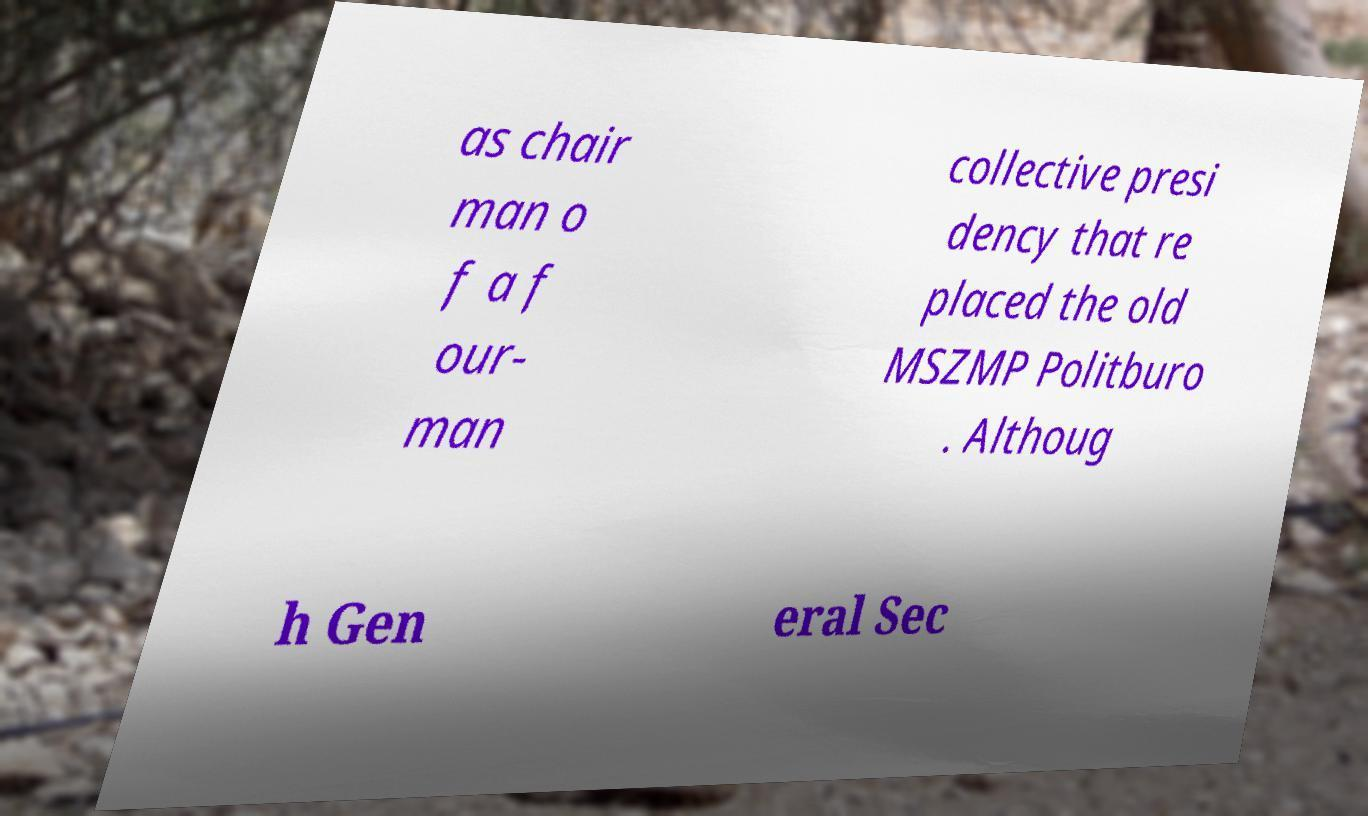Can you accurately transcribe the text from the provided image for me? as chair man o f a f our- man collective presi dency that re placed the old MSZMP Politburo . Althoug h Gen eral Sec 